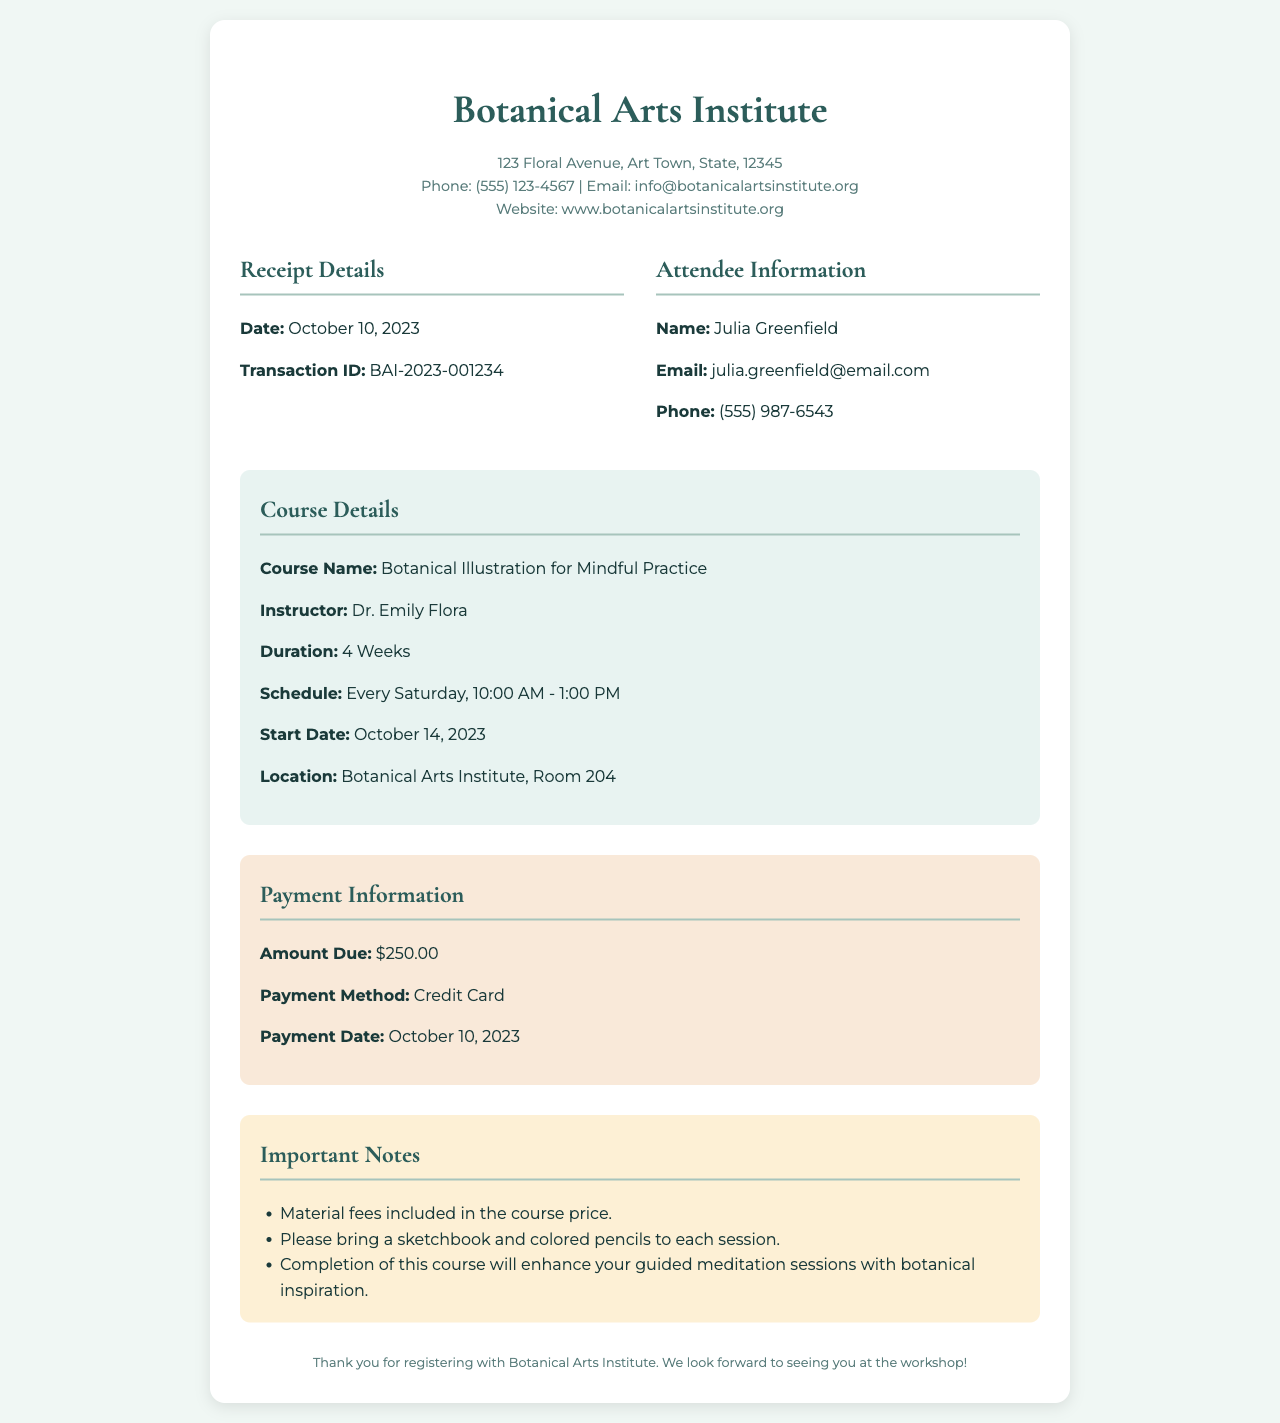What is the name of the course? The course name is specified in the document under course details.
Answer: Botanical Illustration for Mindful Practice Who is the instructor for the course? The instructor's name is mentioned in the course details section.
Answer: Dr. Emily Flora What is the total amount due for the workshop? The amount due is found in the payment information section.
Answer: $250.00 What is the start date of the course? The start date is provided in the course details section.
Answer: October 14, 2023 How long is the duration of the course? The duration is indicated in the course details section.
Answer: 4 Weeks What day of the week are the classes scheduled? The class schedule specifies the day of the week in the course details.
Answer: Every Saturday What should participants bring to each session? This information is listed in the important notes section of the document.
Answer: A sketchbook and colored pencils What is the transaction ID associated with the receipt? The transaction ID can be found in the receipt details section.
Answer: BAI-2023-001234 What are the contact details for the Botanical Arts Institute? The contact details are listed in the organization information at the top of the receipt.
Answer: info@botanicalartsinstitute.org 